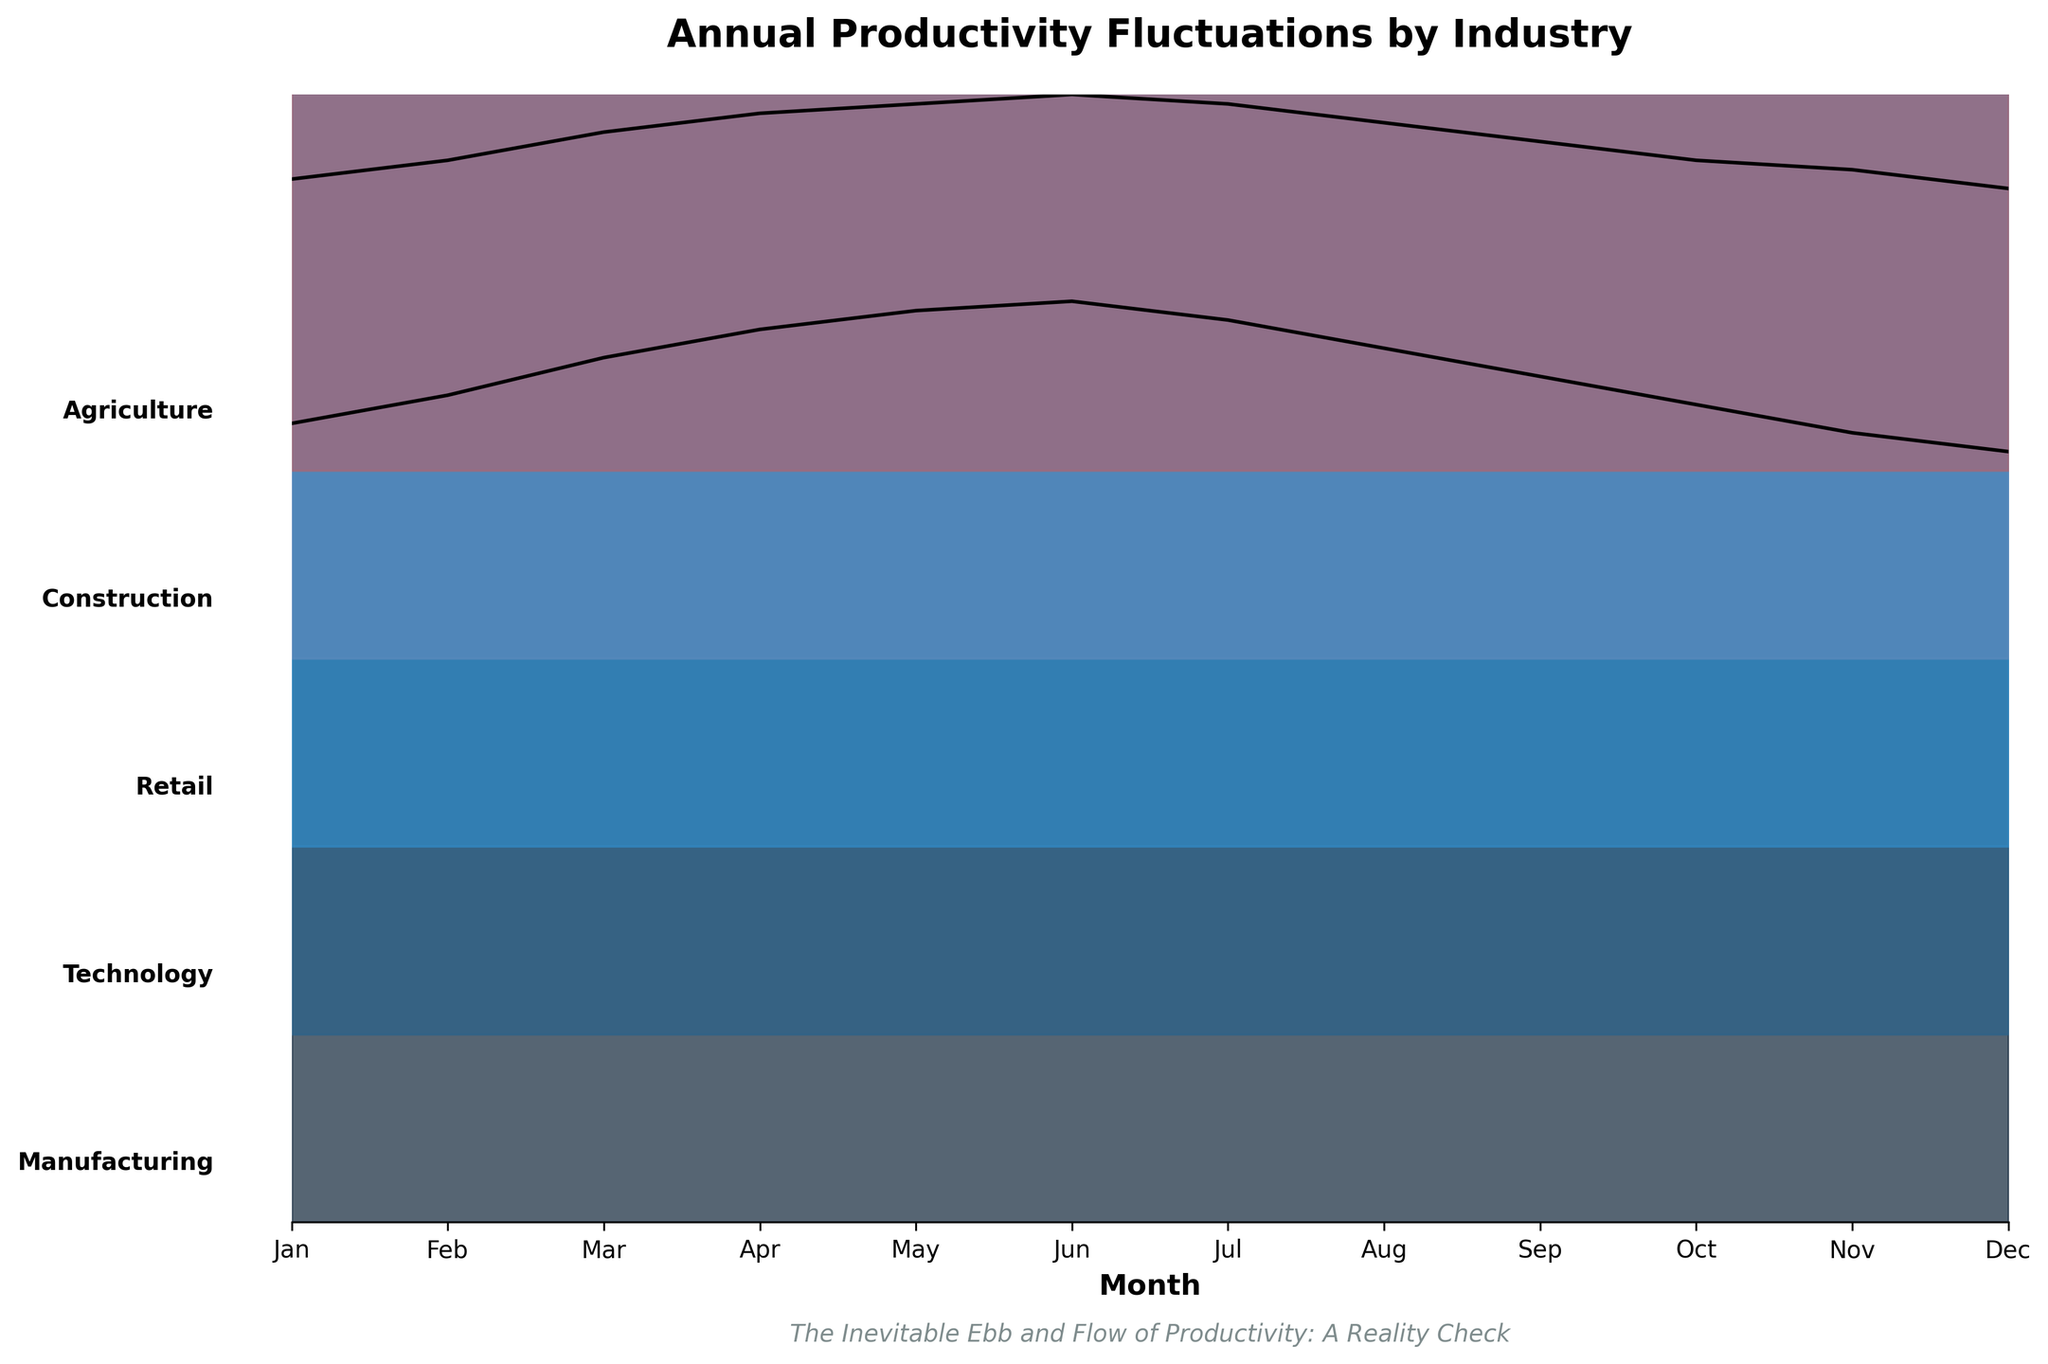What is the title of the figure? The title is usually found at the top of the figure. In the provided code snippet, the title is set as "Annual Productivity Fluctuations by Industry."
Answer: Annual Productivity Fluctuations by Industry Which industry has the highest productivity during December? By examining the end of the lines for December (month 12), the Retail industry line is at the highest position.
Answer: Retail In which month does the Manufacturing industry have its peak productivity? By tracing the Manufacturing line across the months, the peak appears around June (month 6), where the productivity reaches its highest point.
Answer: June Comparing Retail and Construction industries, which one has a higher productivity in November? In November (month 11), the position of the Retail industry line is significantly higher than that of Construction, indicating higher productivity.
Answer: Retail What is the general trend of productivity in the Agriculture industry throughout the year? The Agriculture industry's line starts low in January, increases to a peak around May-June, and then declines again towards December, illustrating a rise and fall pattern.
Answer: Rises and falls Which industry shows the most significant dip in productivity from June to July? By observing the drops between June and July, it is clear that Manufacturing’s line falls significantly.
Answer: Manufacturing How many industries are depicted in the figure? Each distinctly colored line and labeled industry name count as one. There are five industry labels along the Y-axis.
Answer: Five What characteristic is unique to the Retail industry's productivity trend compared to other industries? The Retail industry line shows the most pronounced peak towards the end of the year in December, indicating a significant increase in productivity, likely due to holiday shopping.
Answer: Peak in December In which month do both Technology and Agriculture industries have the same productivity level? By looking for the convergence point of the Technology and Agriculture lines, we see they both level off around June.
Answer: June Based on the cyclical nature shown, which industry appears least impacted by seasonal fluctuations? Comparing the amplitude of fluctuations across the industries, Technology displays relatively stable productivity throughout the year.
Answer: Technology 